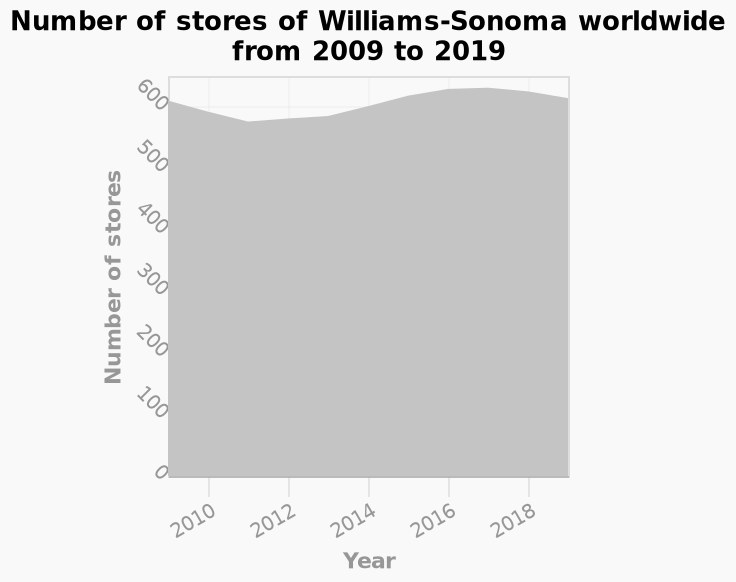<image>
Did the number of stores reach its peak level by 2019? No, the number of stores fluctuated slightly but were at 2009 level by 2019. What does the y-axis represent in the chart?  The y-axis represents the number of stores. 